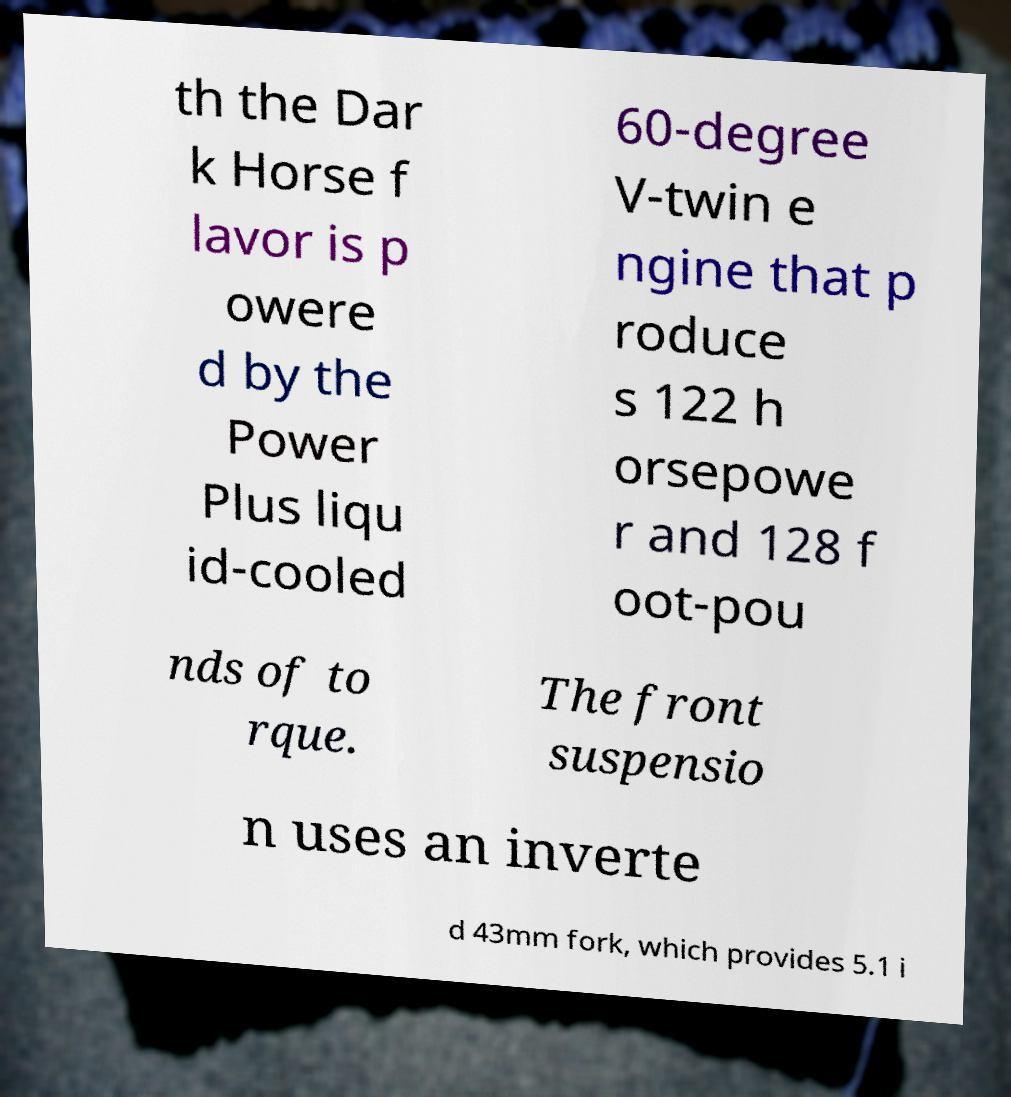Please read and relay the text visible in this image. What does it say? th the Dar k Horse f lavor is p owere d by the Power Plus liqu id-cooled 60-degree V-twin e ngine that p roduce s 122 h orsepowe r and 128 f oot-pou nds of to rque. The front suspensio n uses an inverte d 43mm fork, which provides 5.1 i 